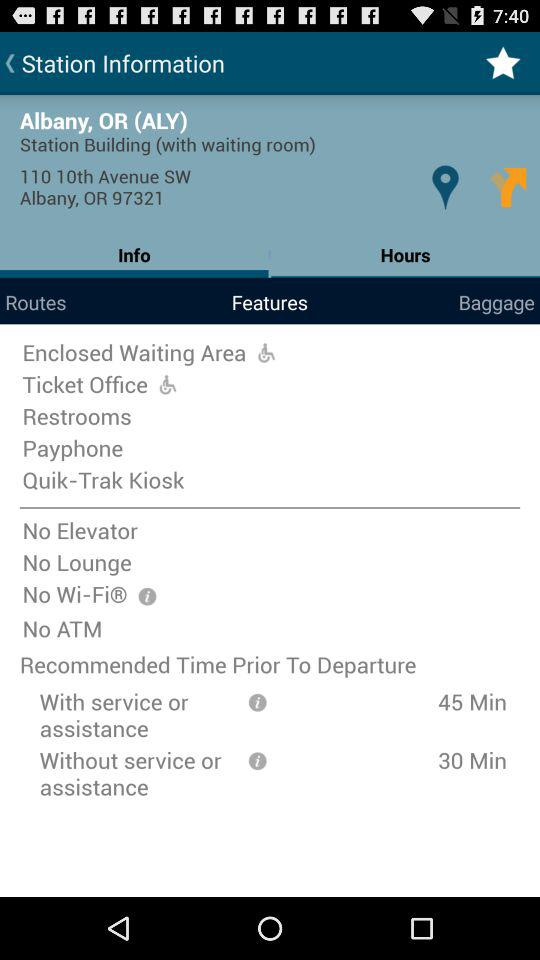Which tab is currently selected? The tab "Features" is currently selected. 